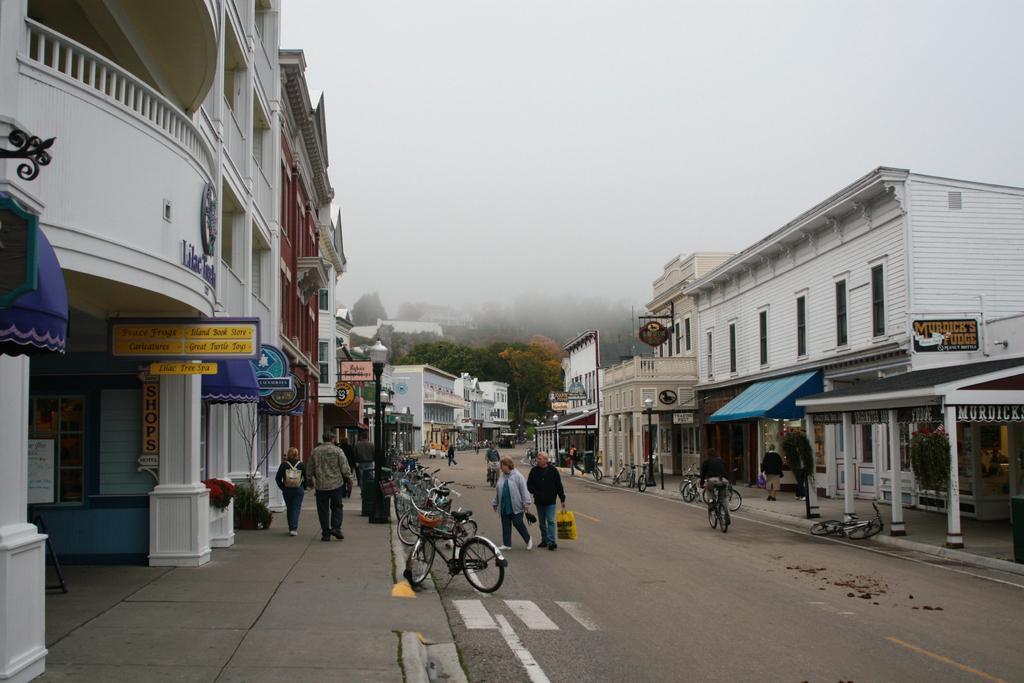Could you give a brief overview of what you see in this image? In this image we can see people, bicycles, bins, poles, lights, plants, boards, pillars, buildings, and trees. In the background there is sky. 